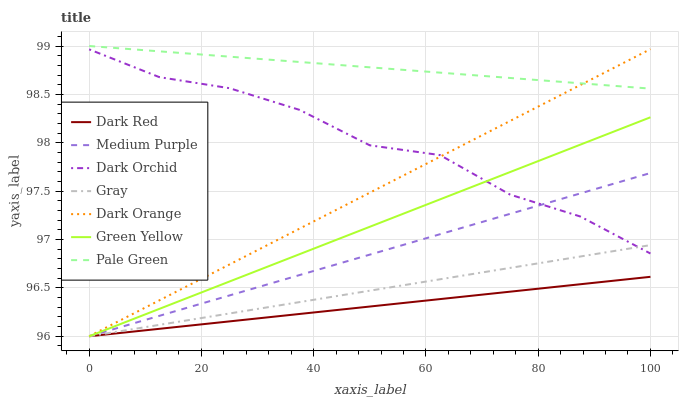Does Dark Red have the minimum area under the curve?
Answer yes or no. Yes. Does Pale Green have the maximum area under the curve?
Answer yes or no. Yes. Does Gray have the minimum area under the curve?
Answer yes or no. No. Does Gray have the maximum area under the curve?
Answer yes or no. No. Is Dark Red the smoothest?
Answer yes or no. Yes. Is Dark Orchid the roughest?
Answer yes or no. Yes. Is Gray the smoothest?
Answer yes or no. No. Is Gray the roughest?
Answer yes or no. No. Does Dark Orange have the lowest value?
Answer yes or no. Yes. Does Dark Orchid have the lowest value?
Answer yes or no. No. Does Pale Green have the highest value?
Answer yes or no. Yes. Does Gray have the highest value?
Answer yes or no. No. Is Gray less than Pale Green?
Answer yes or no. Yes. Is Pale Green greater than Gray?
Answer yes or no. Yes. Does Dark Orchid intersect Dark Orange?
Answer yes or no. Yes. Is Dark Orchid less than Dark Orange?
Answer yes or no. No. Is Dark Orchid greater than Dark Orange?
Answer yes or no. No. Does Gray intersect Pale Green?
Answer yes or no. No. 